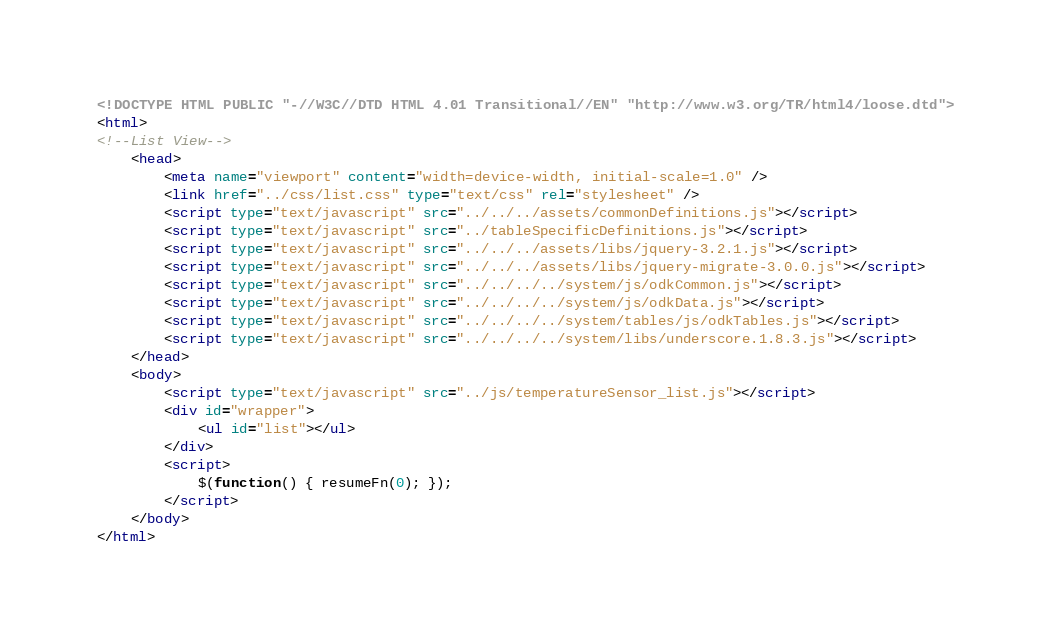Convert code to text. <code><loc_0><loc_0><loc_500><loc_500><_HTML_><!DOCTYPE HTML PUBLIC "-//W3C//DTD HTML 4.01 Transitional//EN" "http://www.w3.org/TR/html4/loose.dtd">
<html>
<!--List View-->
    <head>
        <meta name="viewport" content="width=device-width, initial-scale=1.0" />
        <link href="../css/list.css" type="text/css" rel="stylesheet" />
        <script type="text/javascript" src="../../../assets/commonDefinitions.js"></script>
        <script type="text/javascript" src="../tableSpecificDefinitions.js"></script>
        <script type="text/javascript" src="../../../assets/libs/jquery-3.2.1.js"></script>
        <script type="text/javascript" src="../../../assets/libs/jquery-migrate-3.0.0.js"></script>
        <script type="text/javascript" src="../../../../system/js/odkCommon.js"></script>
        <script type="text/javascript" src="../../../../system/js/odkData.js"></script>
        <script type="text/javascript" src="../../../../system/tables/js/odkTables.js"></script>
        <script type="text/javascript" src="../../../../system/libs/underscore.1.8.3.js"></script>
    </head>
    <body>
        <script type="text/javascript" src="../js/temperatureSensor_list.js"></script>
        <div id="wrapper">
            <ul id="list"></ul>
        </div>
        <script>
            $(function() { resumeFn(0); });
        </script>
    </body>
</html>
</code> 